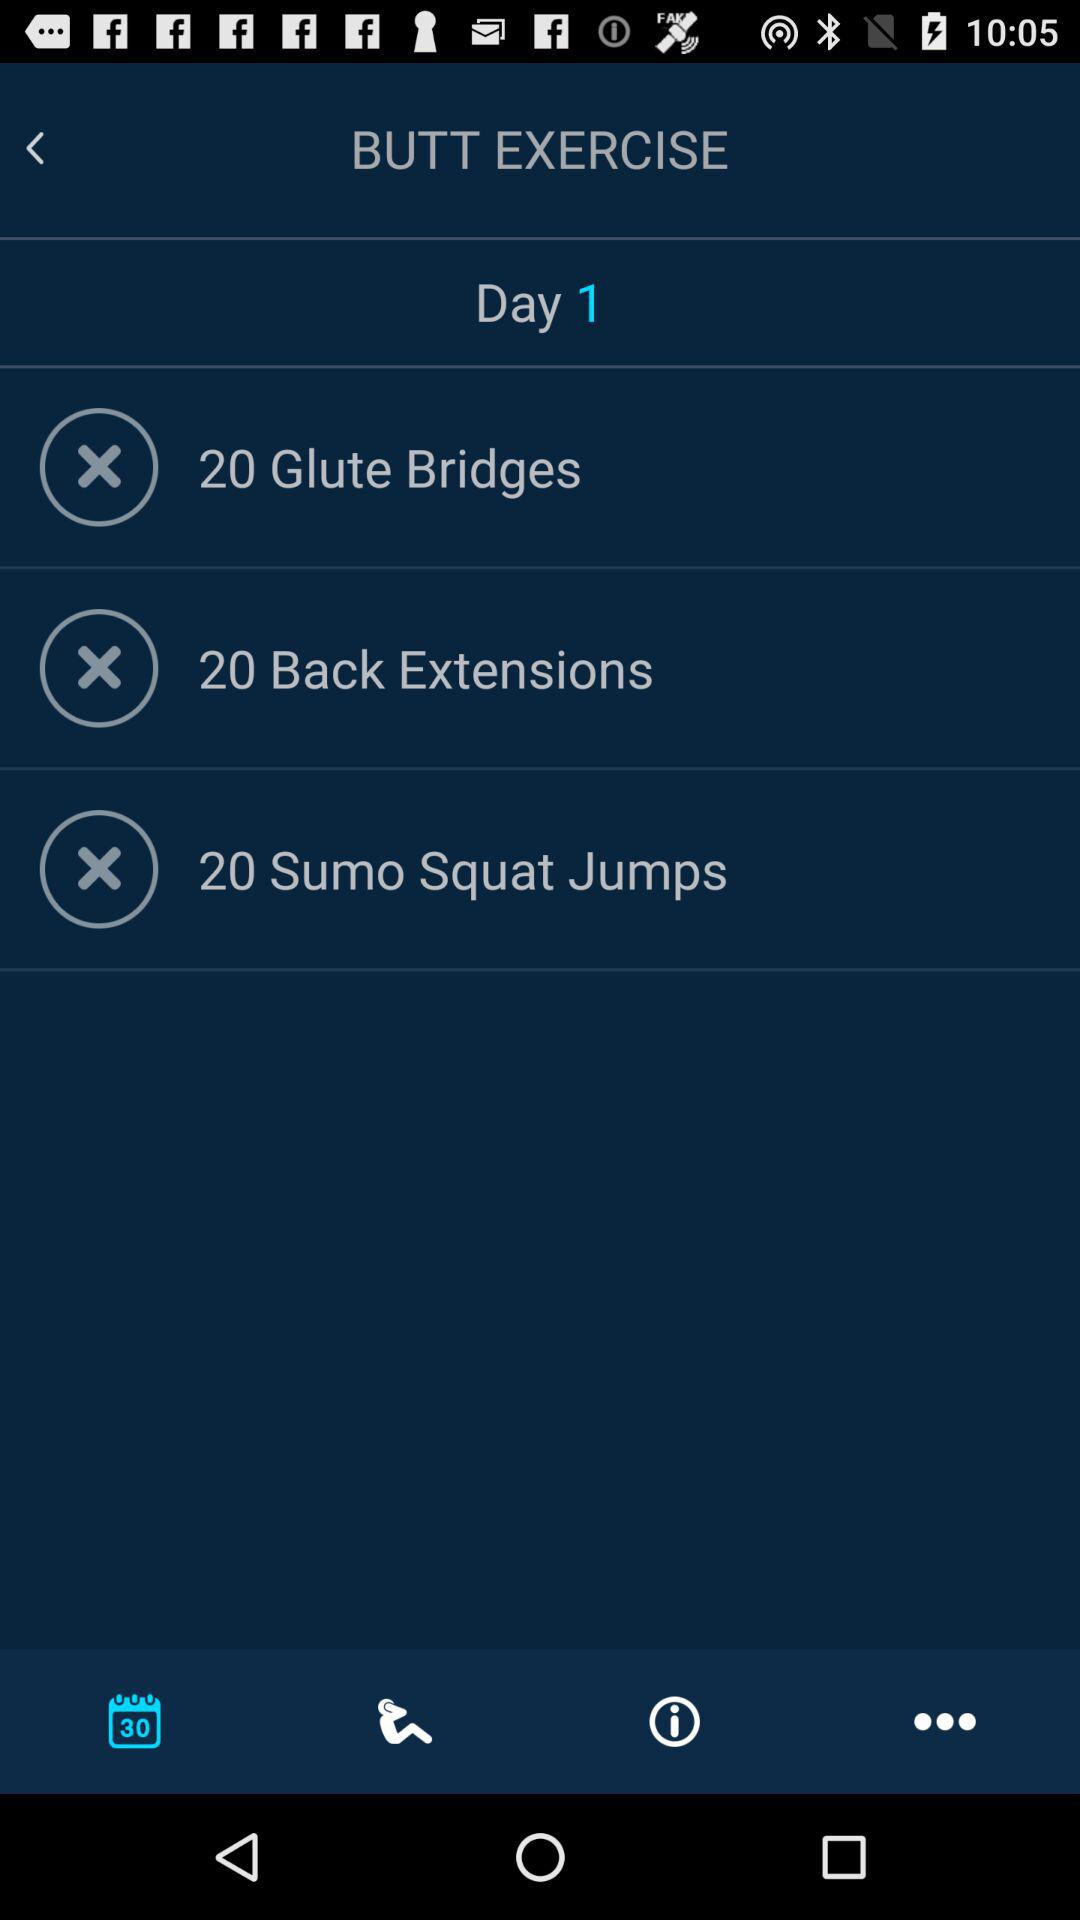Which tab am I on? You are on "Calendar" tab. 